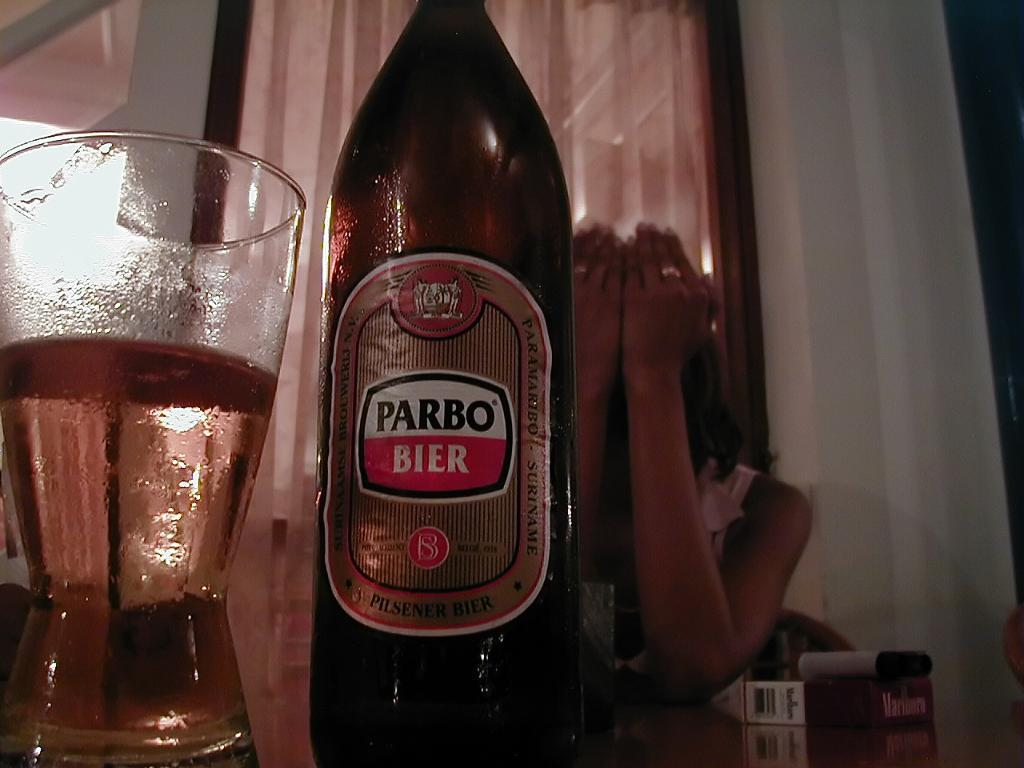<image>
Create a compact narrative representing the image presented. A bottle with the brand name Parbo Bier is next to a glass that is half full. 